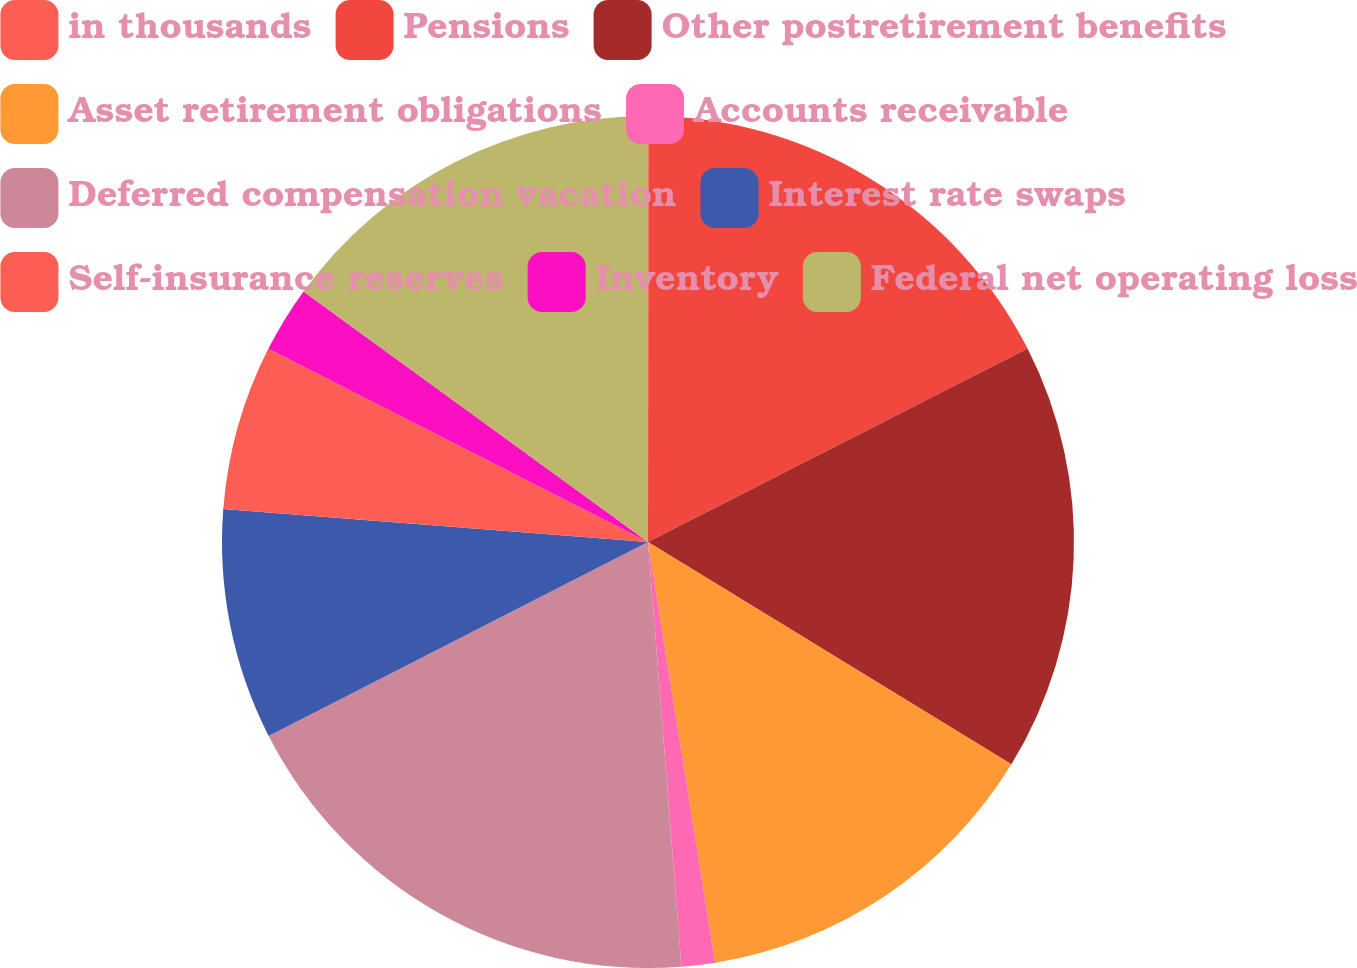Convert chart to OTSL. <chart><loc_0><loc_0><loc_500><loc_500><pie_chart><fcel>in thousands<fcel>Pensions<fcel>Other postretirement benefits<fcel>Asset retirement obligations<fcel>Accounts receivable<fcel>Deferred compensation vacation<fcel>Interest rate swaps<fcel>Self-insurance reserves<fcel>Inventory<fcel>Federal net operating loss<nl><fcel>0.02%<fcel>17.48%<fcel>16.24%<fcel>13.74%<fcel>1.27%<fcel>18.73%<fcel>8.75%<fcel>6.26%<fcel>2.52%<fcel>14.99%<nl></chart> 